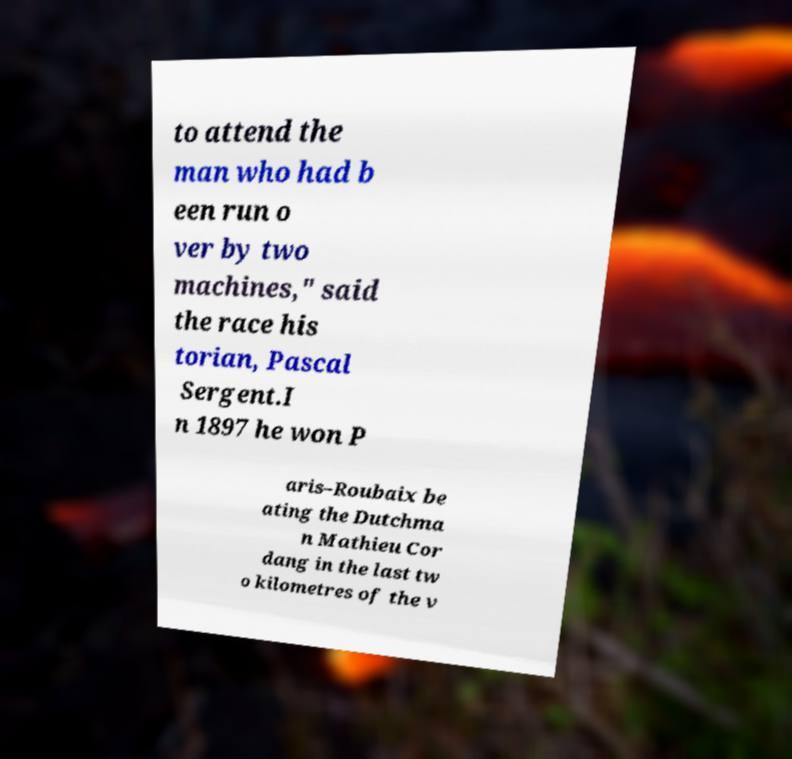I need the written content from this picture converted into text. Can you do that? to attend the man who had b een run o ver by two machines," said the race his torian, Pascal Sergent.I n 1897 he won P aris–Roubaix be ating the Dutchma n Mathieu Cor dang in the last tw o kilometres of the v 